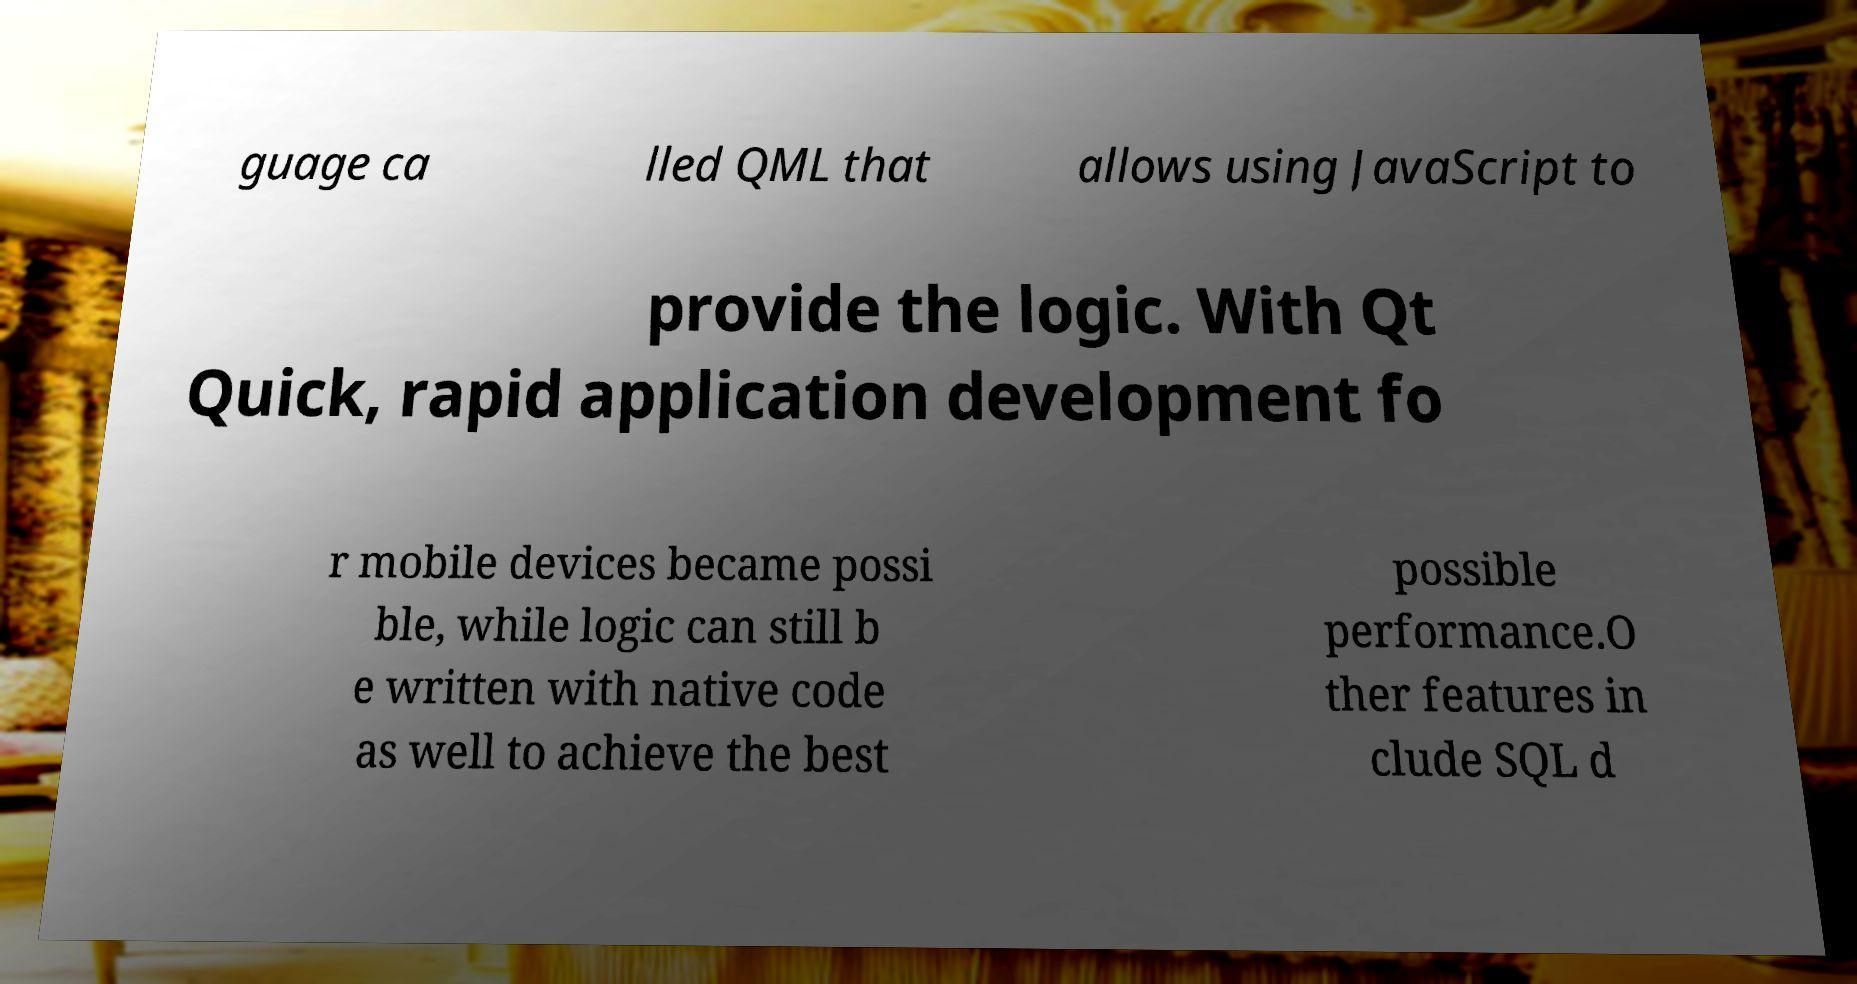Could you assist in decoding the text presented in this image and type it out clearly? guage ca lled QML that allows using JavaScript to provide the logic. With Qt Quick, rapid application development fo r mobile devices became possi ble, while logic can still b e written with native code as well to achieve the best possible performance.O ther features in clude SQL d 